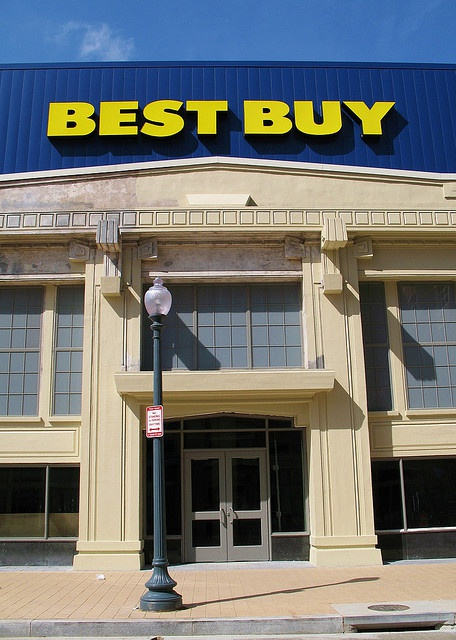Describe the objects in this image and their specific colors. I can see various objects in this image with different colors. 